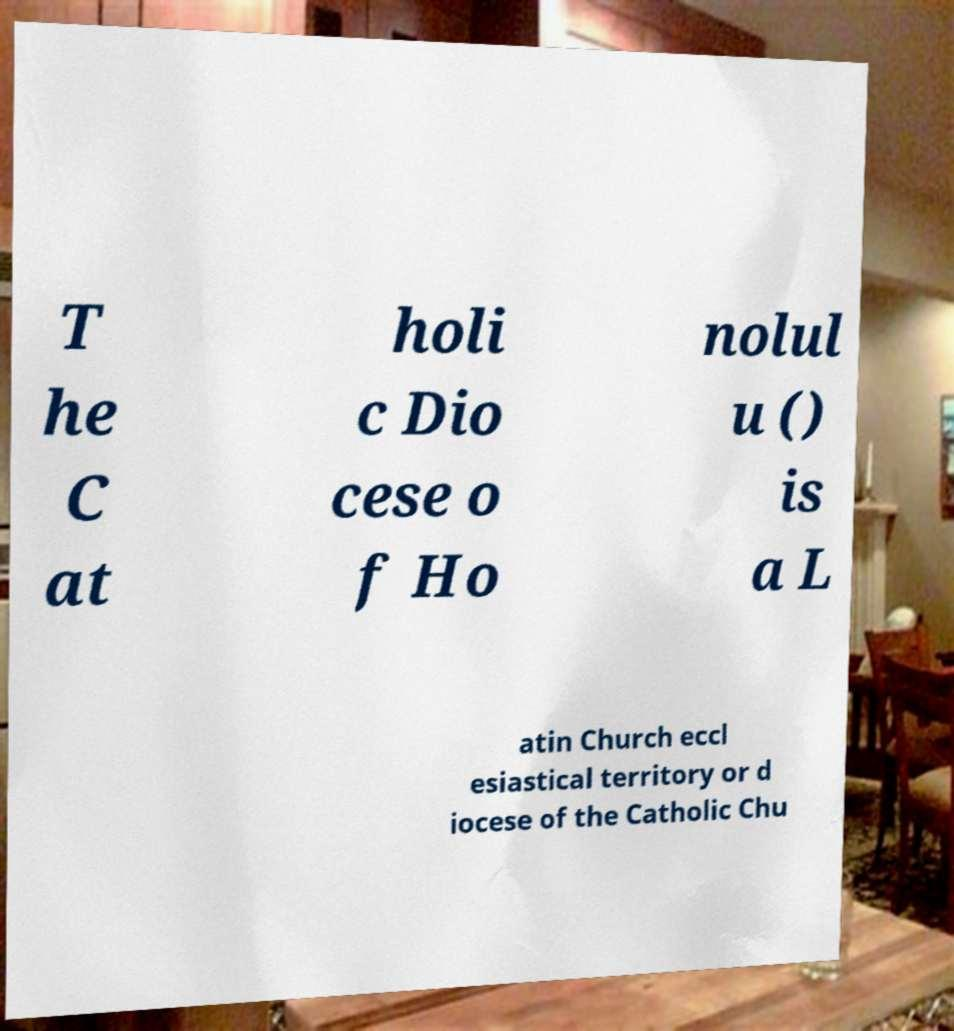Can you read and provide the text displayed in the image?This photo seems to have some interesting text. Can you extract and type it out for me? T he C at holi c Dio cese o f Ho nolul u () is a L atin Church eccl esiastical territory or d iocese of the Catholic Chu 